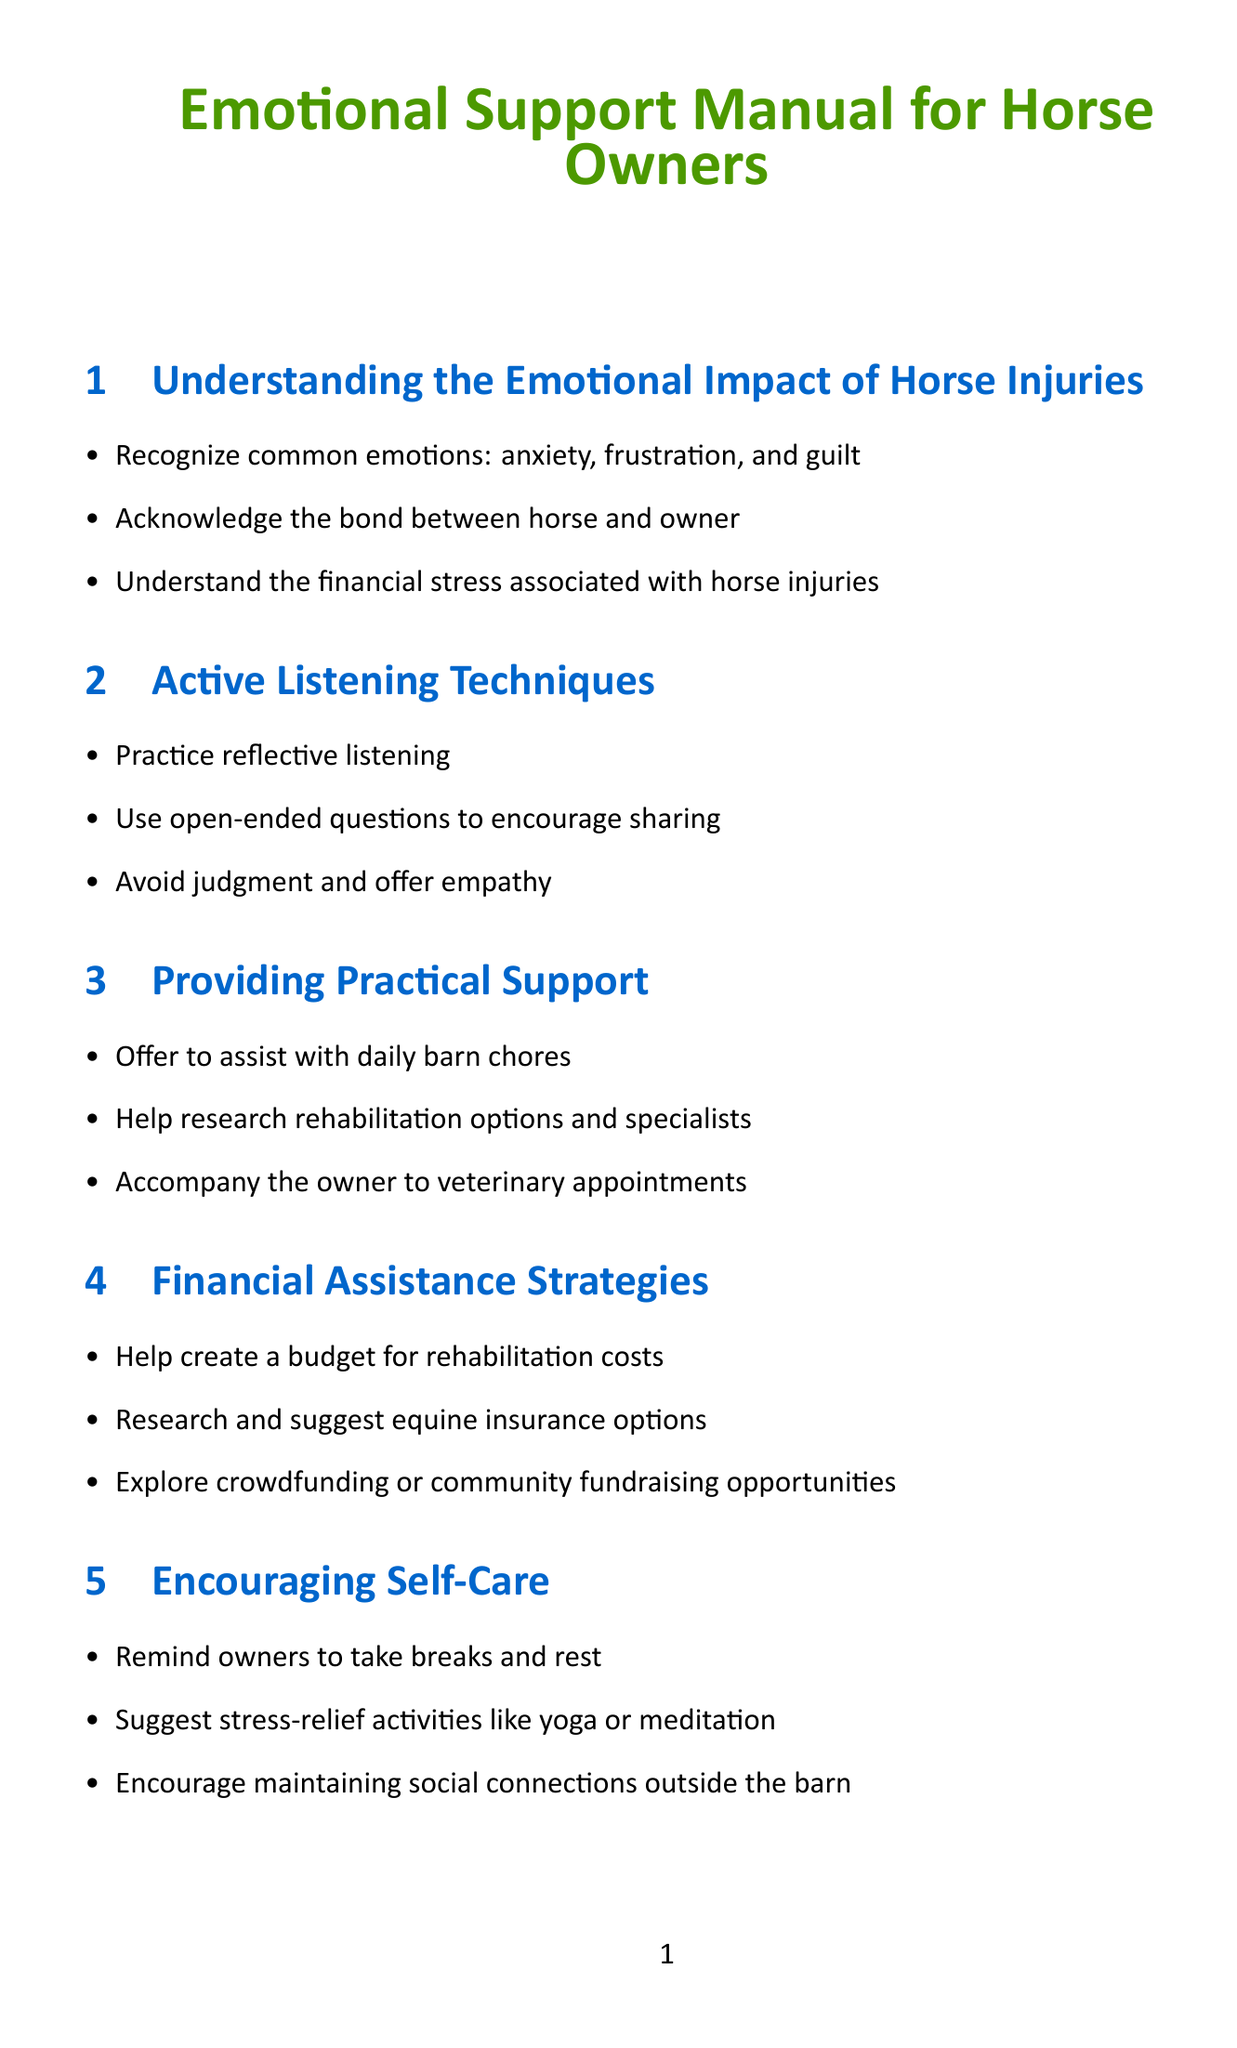What are common emotions experienced by horse owners during injuries? The manual lists the common emotions that horse owners might experience during their horse's injury, which include anxiety, frustration, and guilt.
Answer: anxiety, frustration, guilt What is one technique mentioned for active listening? The manual provides several active listening techniques, and one specific technique is reflective listening.
Answer: reflective listening What should you help the owner create for rehabilitation costs? The manual suggests helping the owner with creating a specific financial plan related to rehabilitation expenses, which is a budget.
Answer: budget What is one self-care suggestion for horse owners? The manual advises owners to engage in self-care practices, one of which is to suggest stress-relief activities.
Answer: stress-relief activities What network can owners connect with for support? The manual introduces support groups for owners, specifically mentioning the Equine Injury Support Network.
Answer: Equine Injury Support Network How often should you check in with the horse owner? The manual emphasizes the importance of maintaining emotional support by regularly checking in with the owner, especially even after recovery, suggesting a frequency that could be considered as regular.
Answer: regularly 